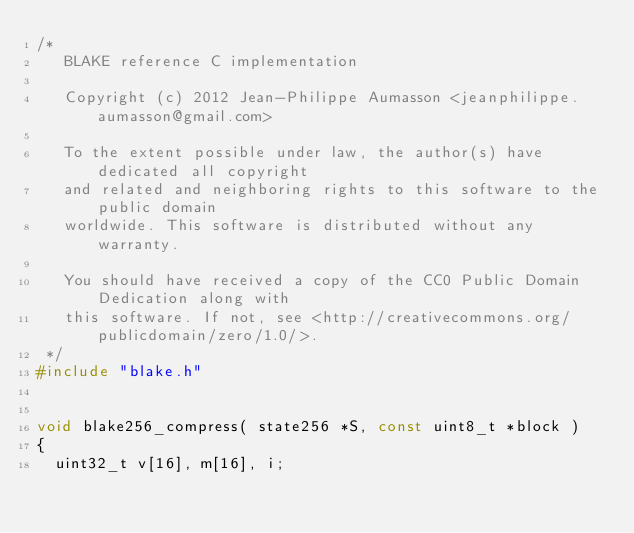Convert code to text. <code><loc_0><loc_0><loc_500><loc_500><_C_>/*
   BLAKE reference C implementation

   Copyright (c) 2012 Jean-Philippe Aumasson <jeanphilippe.aumasson@gmail.com>

   To the extent possible under law, the author(s) have dedicated all copyright
   and related and neighboring rights to this software to the public domain
   worldwide. This software is distributed without any warranty.

   You should have received a copy of the CC0 Public Domain Dedication along with
   this software. If not, see <http://creativecommons.org/publicdomain/zero/1.0/>.
 */
#include "blake.h"


void blake256_compress( state256 *S, const uint8_t *block )
{
  uint32_t v[16], m[16], i;</code> 